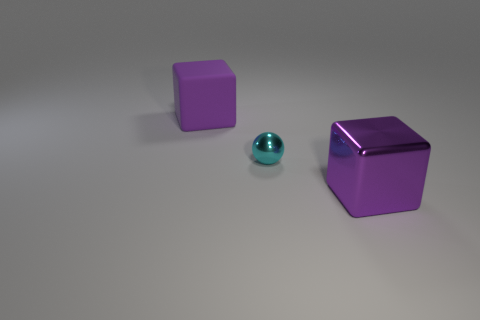What is the size of the other block that is the same color as the matte cube?
Keep it short and to the point. Large. What number of other things are there of the same size as the purple metallic cube?
Provide a succinct answer. 1. What is the size of the thing that is both on the right side of the large rubber thing and behind the metallic block?
Give a very brief answer. Small. How many big purple objects are the same shape as the small thing?
Your answer should be very brief. 0. What material is the small cyan thing?
Your response must be concise. Metal. Is the shape of the cyan metal object the same as the purple rubber object?
Ensure brevity in your answer.  No. Is there a large purple thing made of the same material as the cyan object?
Your answer should be very brief. Yes. There is a object that is both to the right of the large rubber object and behind the metal cube; what is its color?
Keep it short and to the point. Cyan. There is a purple thing in front of the big rubber thing; what is it made of?
Ensure brevity in your answer.  Metal. Is there another big matte object that has the same shape as the big matte thing?
Ensure brevity in your answer.  No. 